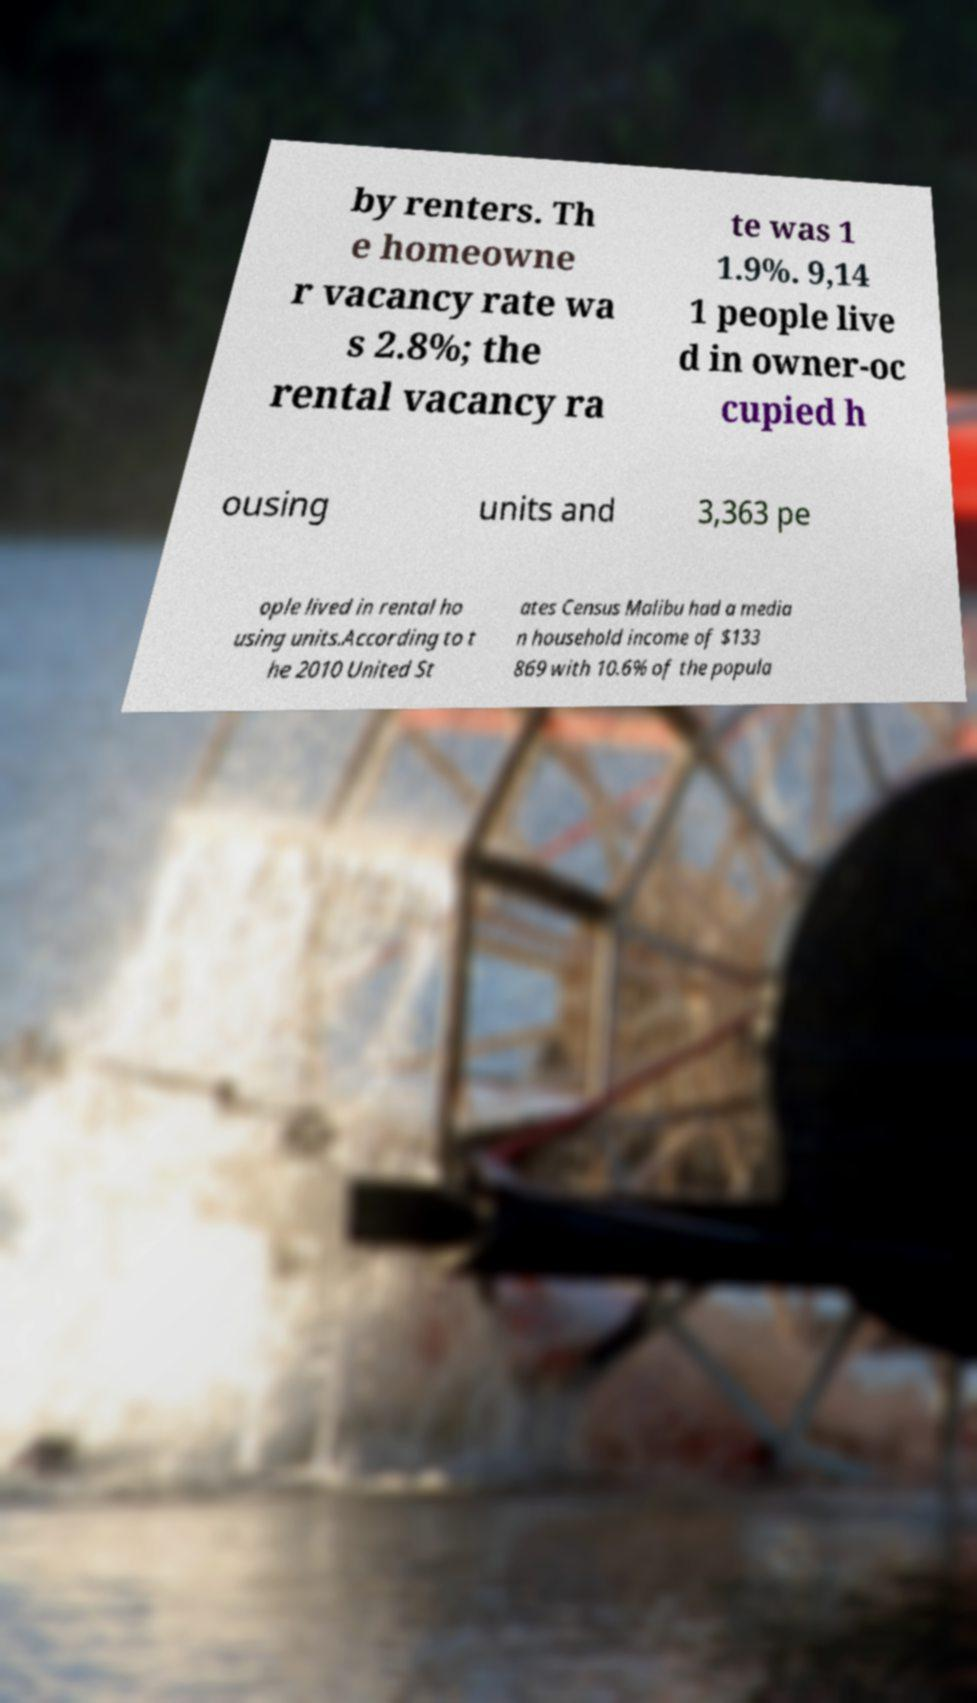What messages or text are displayed in this image? I need them in a readable, typed format. by renters. Th e homeowne r vacancy rate wa s 2.8%; the rental vacancy ra te was 1 1.9%. 9,14 1 people live d in owner-oc cupied h ousing units and 3,363 pe ople lived in rental ho using units.According to t he 2010 United St ates Census Malibu had a media n household income of $133 869 with 10.6% of the popula 